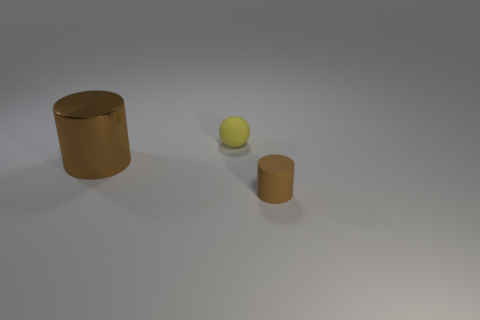Add 2 small purple cylinders. How many objects exist? 5 Add 2 tiny brown matte cylinders. How many tiny brown matte cylinders are left? 3 Add 3 tiny rubber spheres. How many tiny rubber spheres exist? 4 Subtract 0 blue cylinders. How many objects are left? 3 Subtract all balls. How many objects are left? 2 Subtract all red spheres. Subtract all green cubes. How many spheres are left? 1 Subtract all blue matte spheres. Subtract all matte things. How many objects are left? 1 